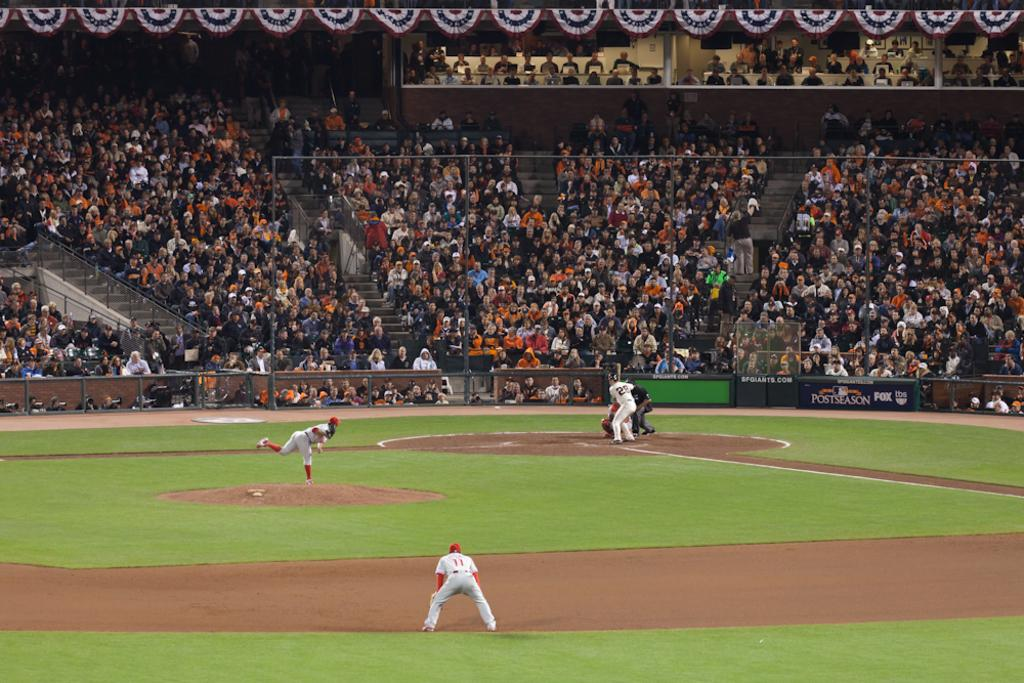What type of structure is shown in the image? There is a stadium in the image. What activity is taking place in the stadium? There are people playing a game in the stadium. Can you describe any specific features of the stadium? There are boards and stairs visible in the image. Who else is present in the image besides the people playing the game? There is a group of people in the image. What else can be seen in the image besides the people and the stadium? There are some objects in the image. What grade is the student studying in the bedroom in the image? There is no bedroom or student present in the image; it features a stadium with people playing a game. What type of rod can be seen holding up the curtains in the image? There are no curtains or rods present in the image; it shows a stadium with people playing a game. 